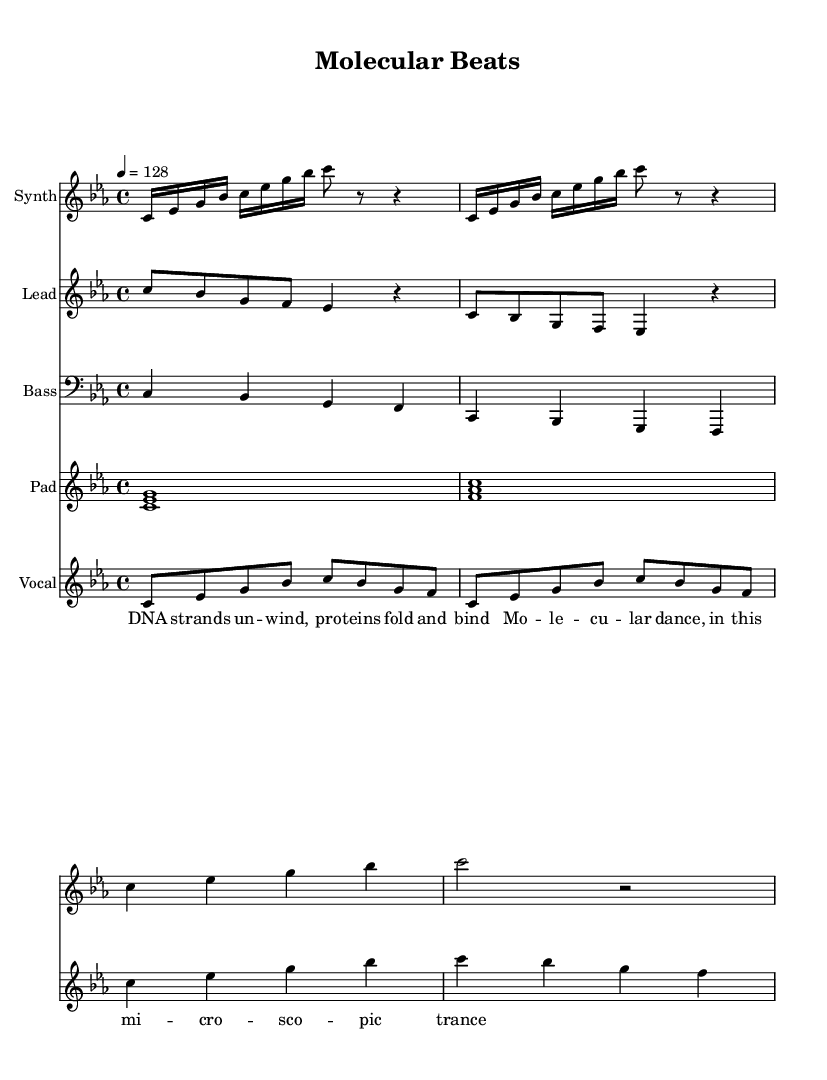What is the key signature of this music? The key signature is C minor, which includes three flats (B flat, E flat, and A flat). This is determined from the key signature indicated at the beginning of the sheet music.
Answer: C minor What is the time signature of this music? The time signature is 4/4, meaning there are four beats in each measure and the quarter note gets one beat. This can be observed next to the clef at the start of the score.
Answer: 4/4 What is the tempo marking for this piece? The tempo marking indicates a tempo of 128 beats per minute, which is shown at the beginning of the score with the notation "4 = 128."
Answer: 128 How many measures are in the synth intro? The synth intro consists of 4 measures, as it repeats a pattern of 2 measures twice. The repetition can be seen in the repeated section notation.
Answer: 4 Which instruments are used in this score? The instruments in this score include Synth, Lead, Bass, Pad, and Vocal. This is presented in the instrument names specified in each staff at the beginning of the score.
Answer: Synth, Lead, Bass, Pad, Vocal What is the lyrical theme based on the vocal verse? The lyrical theme involves molecular biology, referencing DNA and proteins during the vocal verse. The specific words indicate a focus on biological processes.
Answer: DNA, proteins What is the overall structure of the track? The overall structure alternates between verses and choruses, typical in house music, creating a repetitive and engaging pattern for dancing. This can be inferred from the layout of the sections labeled as "Verse" and "Chorus."
Answer: Verse-Chorus 